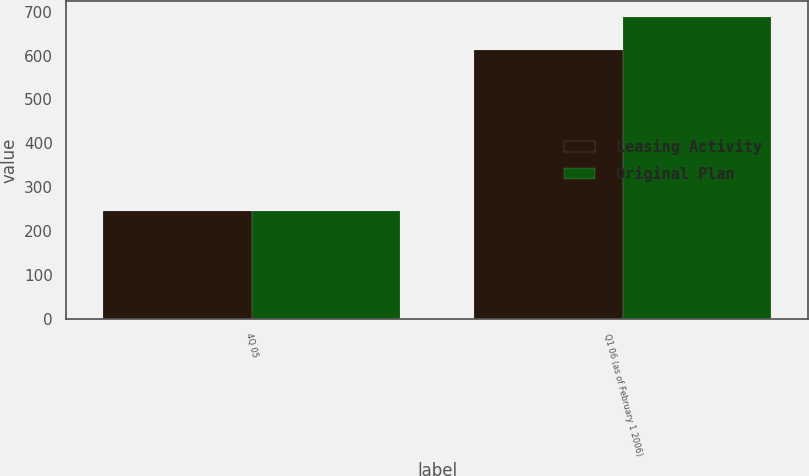<chart> <loc_0><loc_0><loc_500><loc_500><stacked_bar_chart><ecel><fcel>4Q 05<fcel>Q1 06 (as of February 1 2006)<nl><fcel>Leasing Activity<fcel>247<fcel>612<nl><fcel>Original Plan<fcel>247<fcel>689<nl></chart> 